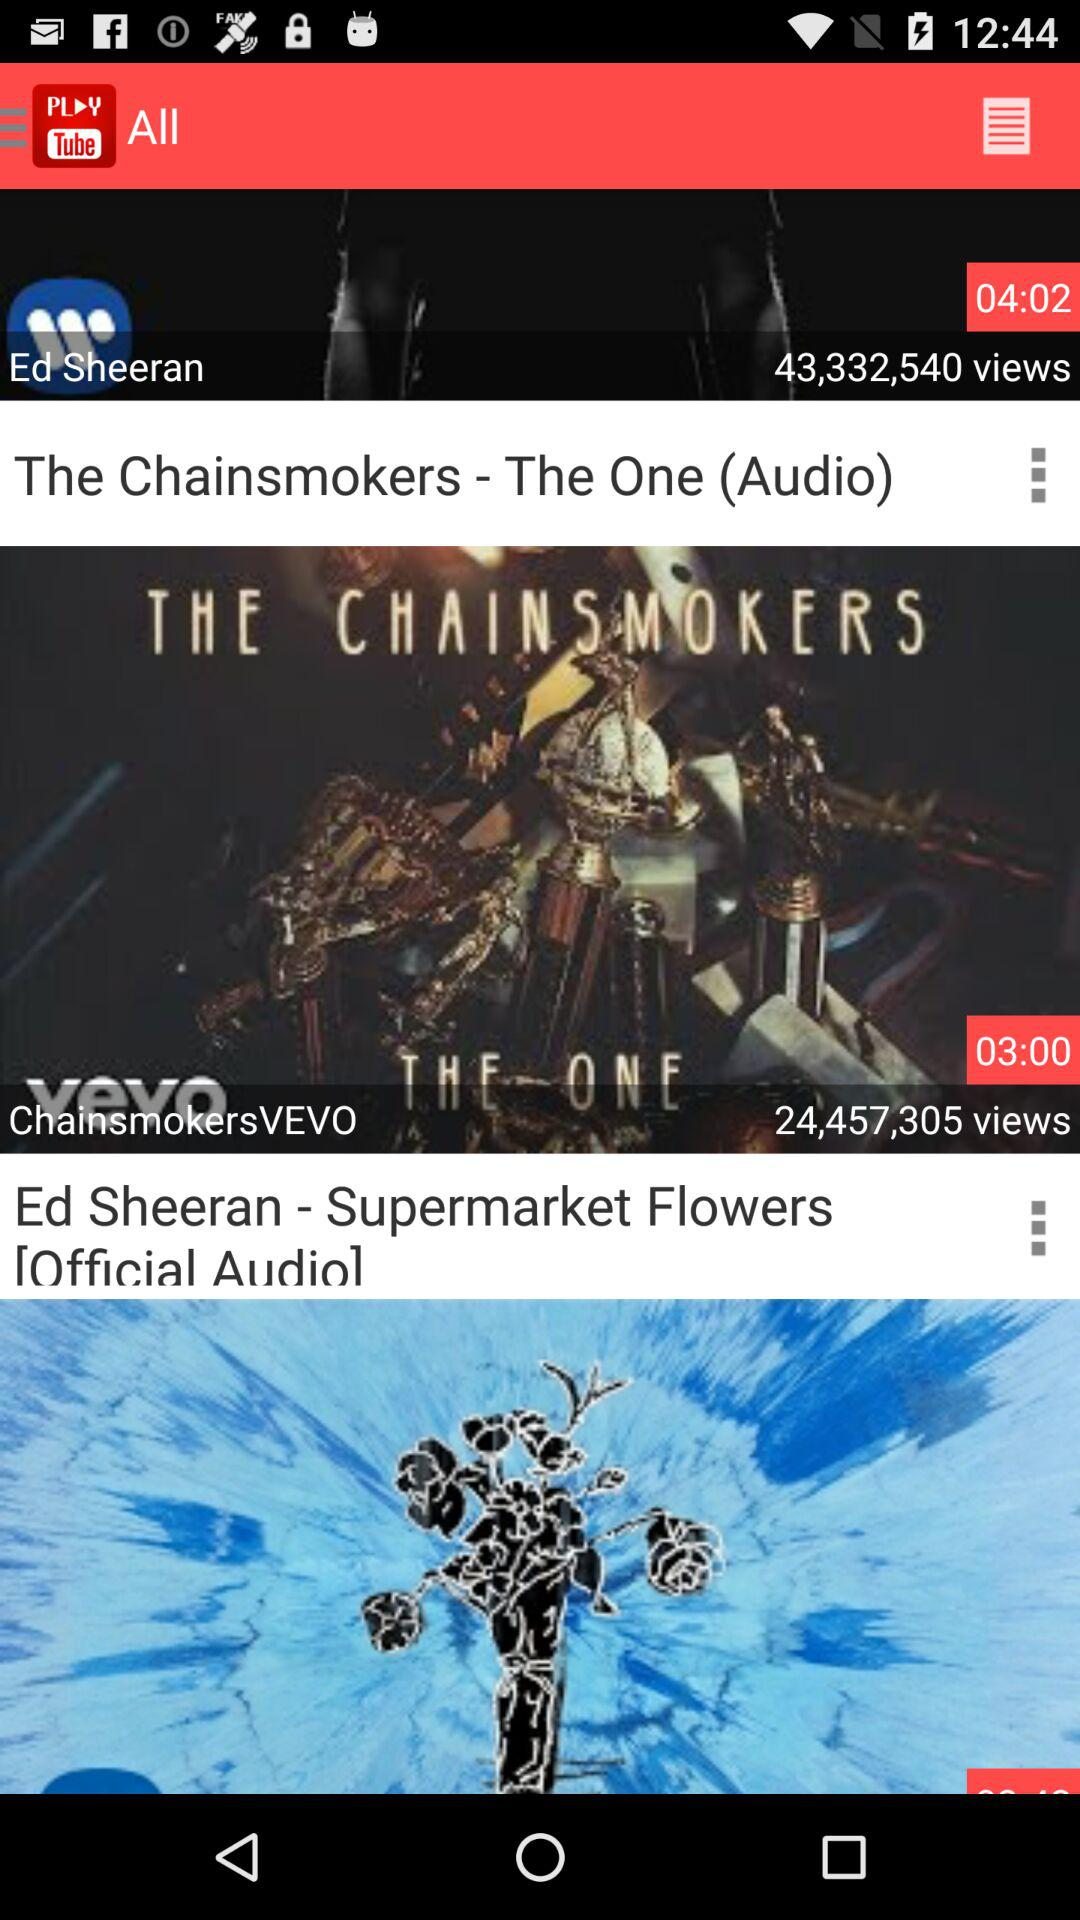How many views has the video by Ed Sheeran received? The video by Ed Sheeran received 43,332,540 views. 